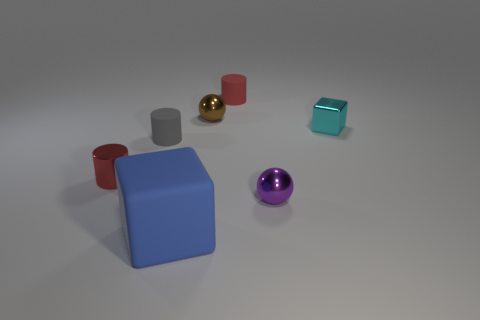There is a metallic cube that is the same size as the red rubber object; what color is it?
Your answer should be very brief. Cyan. How many objects are red cylinders or small red matte balls?
Your answer should be compact. 2. There is a red cylinder behind the red object that is in front of the tiny rubber cylinder that is on the right side of the gray matte thing; how big is it?
Keep it short and to the point. Small. How many other large rubber blocks are the same color as the big matte block?
Your answer should be compact. 0. What number of tiny objects are made of the same material as the big thing?
Provide a succinct answer. 2. What number of things are either big blue rubber cylinders or things in front of the tiny gray rubber thing?
Make the answer very short. 3. What color is the ball on the left side of the ball in front of the small matte cylinder that is to the left of the red matte thing?
Make the answer very short. Brown. There is a red cylinder that is to the right of the brown shiny object; what is its size?
Provide a succinct answer. Small. How many big things are either red objects or metal things?
Your answer should be compact. 0. The matte thing that is in front of the brown sphere and behind the big rubber object is what color?
Ensure brevity in your answer.  Gray. 